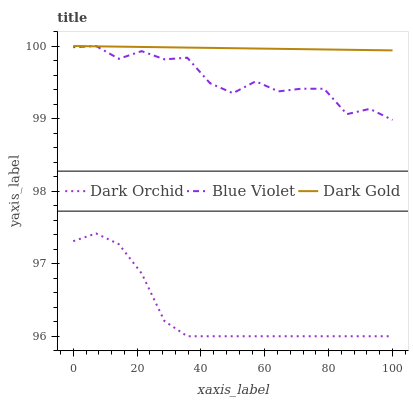Does Dark Orchid have the minimum area under the curve?
Answer yes or no. Yes. Does Dark Gold have the maximum area under the curve?
Answer yes or no. Yes. Does Dark Gold have the minimum area under the curve?
Answer yes or no. No. Does Dark Orchid have the maximum area under the curve?
Answer yes or no. No. Is Dark Gold the smoothest?
Answer yes or no. Yes. Is Blue Violet the roughest?
Answer yes or no. Yes. Is Dark Orchid the smoothest?
Answer yes or no. No. Is Dark Orchid the roughest?
Answer yes or no. No. Does Dark Orchid have the lowest value?
Answer yes or no. Yes. Does Dark Gold have the lowest value?
Answer yes or no. No. Does Dark Gold have the highest value?
Answer yes or no. Yes. Does Dark Orchid have the highest value?
Answer yes or no. No. Is Dark Orchid less than Dark Gold?
Answer yes or no. Yes. Is Dark Gold greater than Dark Orchid?
Answer yes or no. Yes. Does Dark Gold intersect Blue Violet?
Answer yes or no. Yes. Is Dark Gold less than Blue Violet?
Answer yes or no. No. Is Dark Gold greater than Blue Violet?
Answer yes or no. No. Does Dark Orchid intersect Dark Gold?
Answer yes or no. No. 